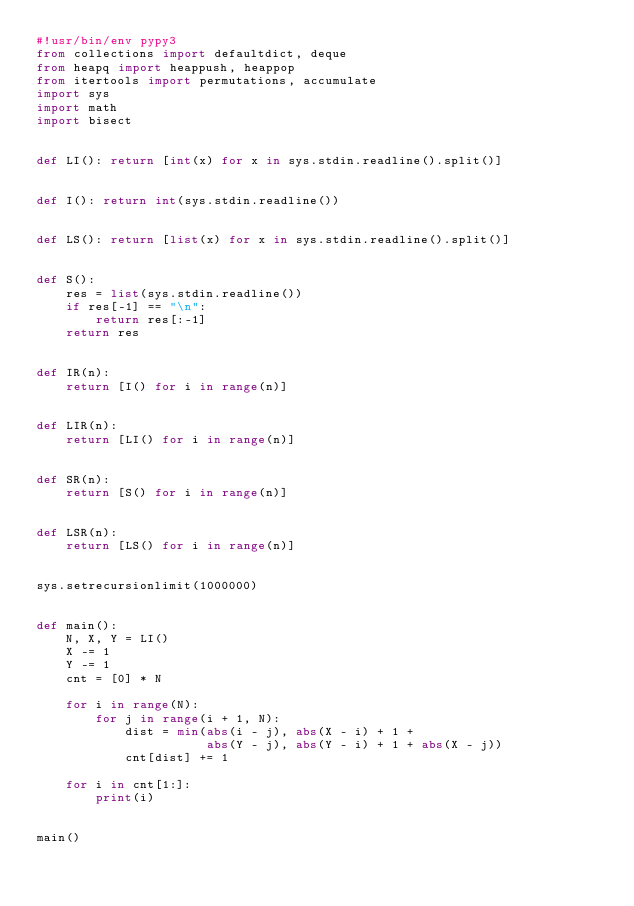<code> <loc_0><loc_0><loc_500><loc_500><_Python_>#!usr/bin/env pypy3
from collections import defaultdict, deque
from heapq import heappush, heappop
from itertools import permutations, accumulate
import sys
import math
import bisect


def LI(): return [int(x) for x in sys.stdin.readline().split()]


def I(): return int(sys.stdin.readline())


def LS(): return [list(x) for x in sys.stdin.readline().split()]


def S():
    res = list(sys.stdin.readline())
    if res[-1] == "\n":
        return res[:-1]
    return res


def IR(n):
    return [I() for i in range(n)]


def LIR(n):
    return [LI() for i in range(n)]


def SR(n):
    return [S() for i in range(n)]


def LSR(n):
    return [LS() for i in range(n)]


sys.setrecursionlimit(1000000)


def main():
    N, X, Y = LI()
    X -= 1
    Y -= 1
    cnt = [0] * N

    for i in range(N):
        for j in range(i + 1, N):
            dist = min(abs(i - j), abs(X - i) + 1 +
                       abs(Y - j), abs(Y - i) + 1 + abs(X - j))
            cnt[dist] += 1

    for i in cnt[1:]:
        print(i)


main()
</code> 